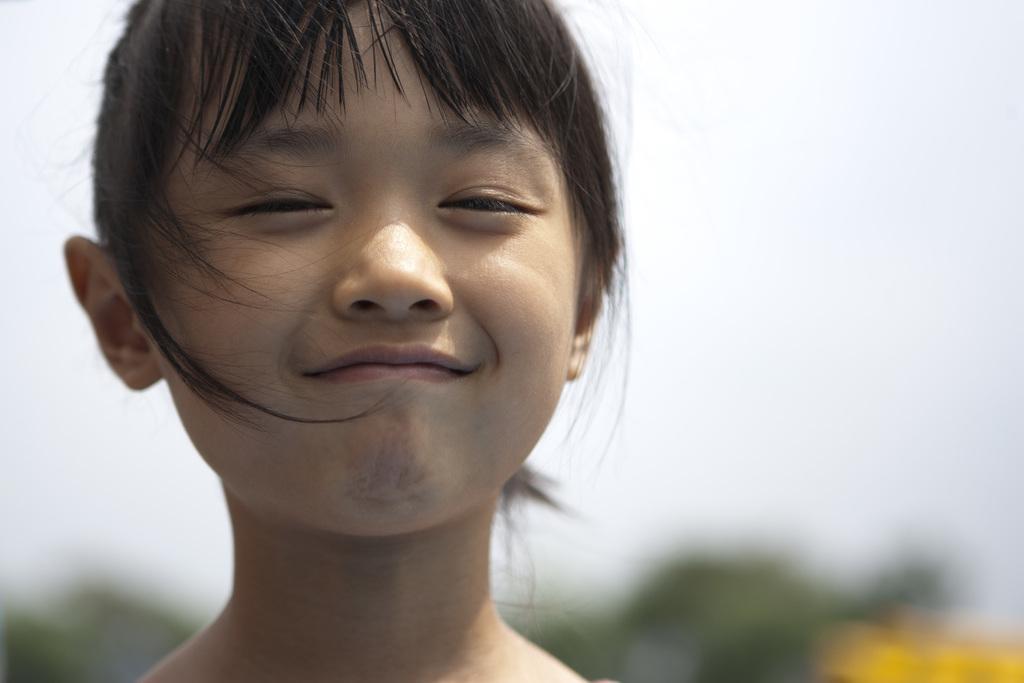Please provide a concise description of this image. In this image there is a face of a girl who is smiling. 